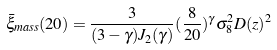<formula> <loc_0><loc_0><loc_500><loc_500>\bar { \xi } _ { m a s s } ( 2 0 ) = \frac { 3 } { ( 3 - \gamma ) J _ { 2 } ( \gamma ) } ( \frac { 8 } { 2 0 } ) ^ { \gamma } \sigma _ { 8 } ^ { 2 } D ( z ) ^ { 2 }</formula> 